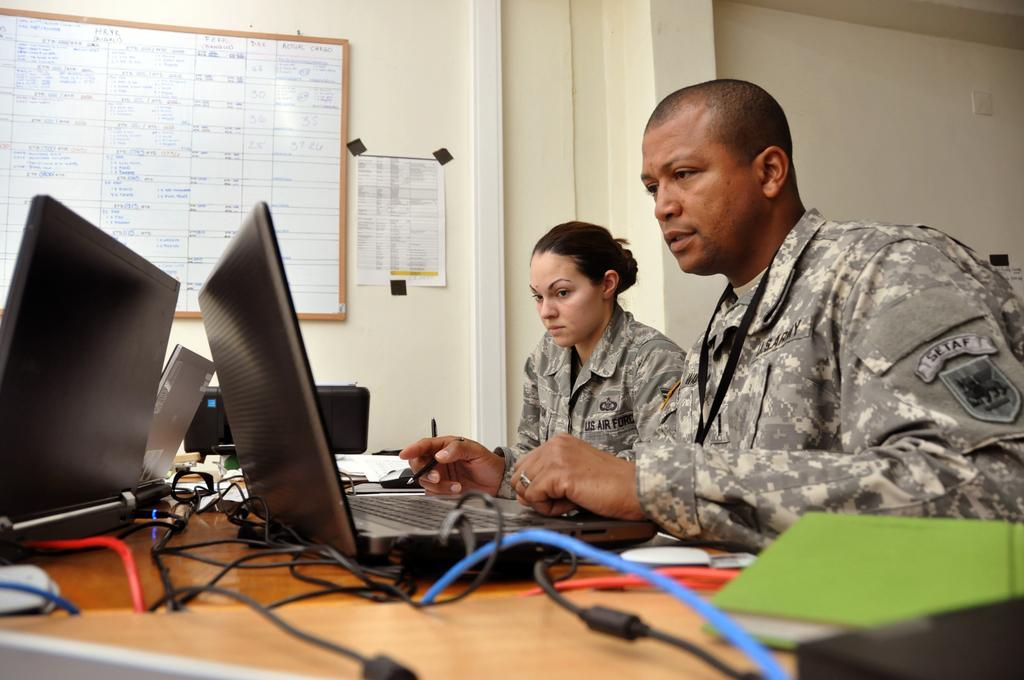<image>
Summarize the visual content of the image. Two people sit by each other wearing military uniforms with one saying SETAF. 